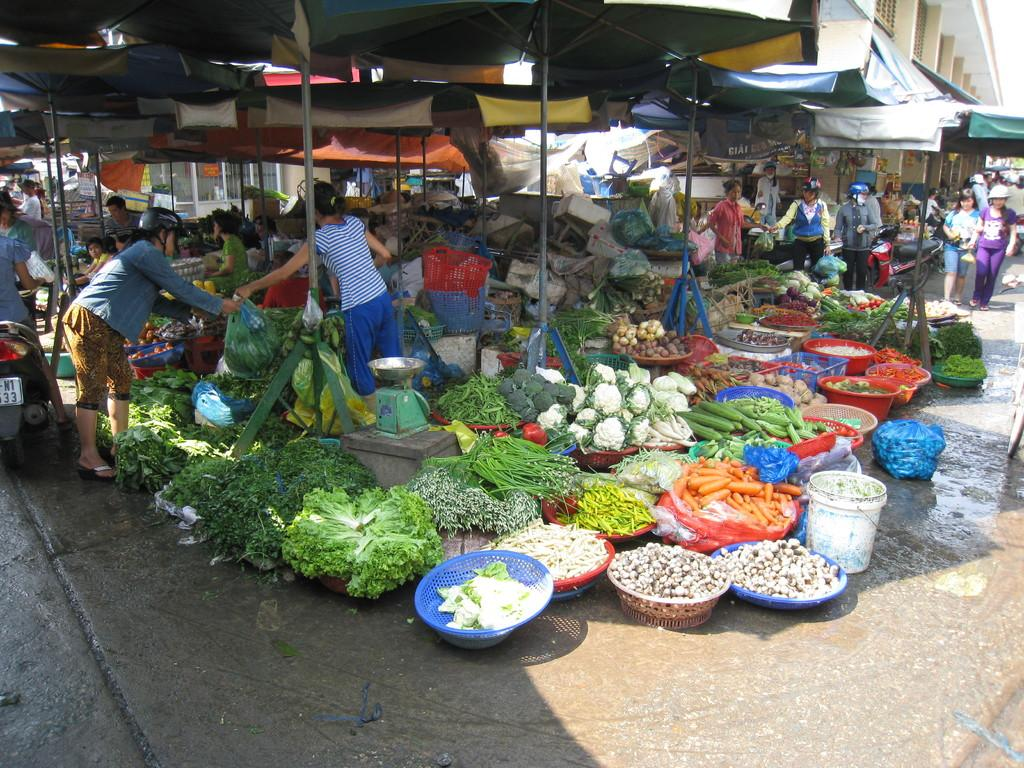What type of location is depicted in the image? The image depicts a vegetable market. What structures can be seen in the image? There are tents and at least one building in the image. Who is present in the image? There are people in the image. What objects are used for support or display in the image? There are poles, baskets, and a bucket in the image. What mode of transportation is visible in the image? A motorbike is visible in the image. What type of items are being sold at the market? Vegetables are present in the image. What type of ray is visible in the image? There is no mention of a ray in the image. --- Facts: 1. There is a river in the image. 12. There are boats on the river. 13. There are trees along the river. 14. There are people near the river. 15. There is a bridge over the river. 16. There are rocks in the river. 17. There are birds flying above the river. 18. There is a waterfall in the background of the image. 19. There is a mountain in the background of the image. 120. There are clouds in the sky. Absurd Topics: unicorn, magic wand, invisible ink Conversation: What type of water body is present in the image? There is a river in the image. What type of vehicles can be seen in the image? There are boats on the river in the image. What type of vegetation is present along the river? There are trees along the river in the image. Who is present near the river in the image? There are people near the river in the image. What type of structure is present over the river in the image? There is a bridge over the river in the image. What type of natural elements are present in the river in the image? There are rocks in the river in the image. What type of animals can be seen flying above the river in the image? There are birds flying above the river in the image. What type of natural landmark is present in the background of the image? There is a waterfall in the background of the image. What type of natural landmark is present in the background of the image? There is a mountain in the background of the image. What type of natural atmospheric elements are present in the sky in the image? There are clouds in the sky in the image. Reasoning: Let's think step by step in order to produce the conversation. We start by identifying the main subject and theme of the image, which is a river with various elements and objects present around it. Then, we describe the various structures, objects, and people present in the image. We ensure that each question can be answered definitively with the information given. Absurd Question/Answer: 